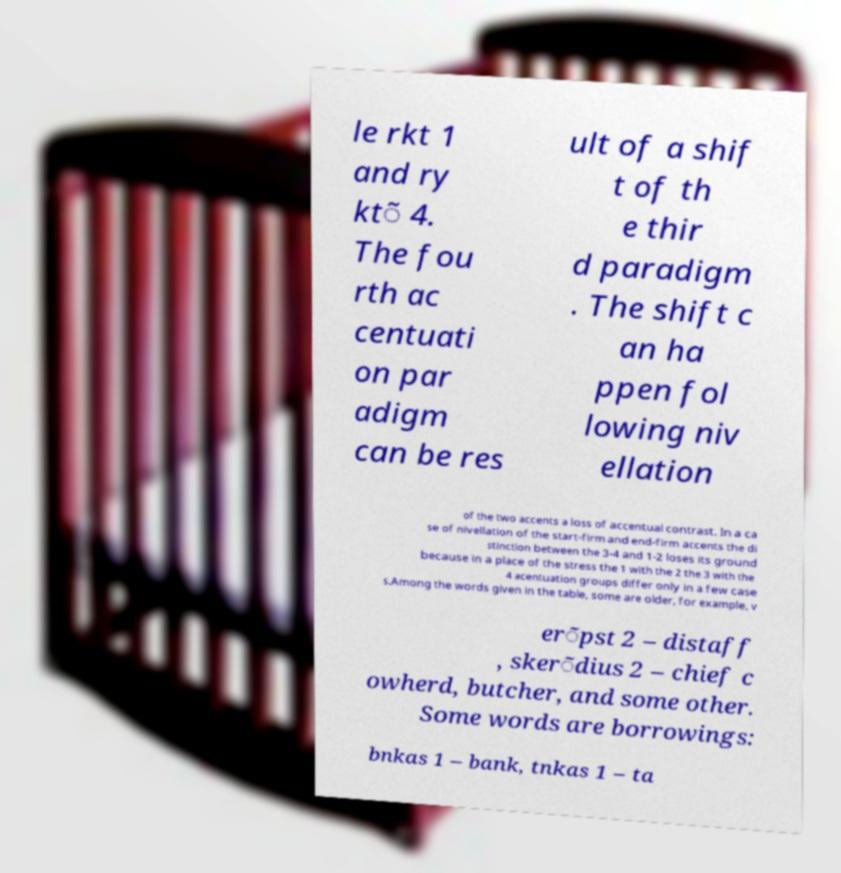Please identify and transcribe the text found in this image. le rkt 1 and ry kt̃ 4. The fou rth ac centuati on par adigm can be res ult of a shif t of th e thir d paradigm . The shift c an ha ppen fol lowing niv ellation of the two accents a loss of accentual contrast. In a ca se of nivellation of the start-firm and end-firm accents the di stinction between the 3-4 and 1-2 loses its ground because in a place of the stress the 1 with the 2 the 3 with the 4 acentuation groups differ only in a few case s.Among the words given in the table, some are older, for example, v er̃pst 2 – distaff , sker̃dius 2 – chief c owherd, butcher, and some other. Some words are borrowings: bnkas 1 – bank, tnkas 1 – ta 